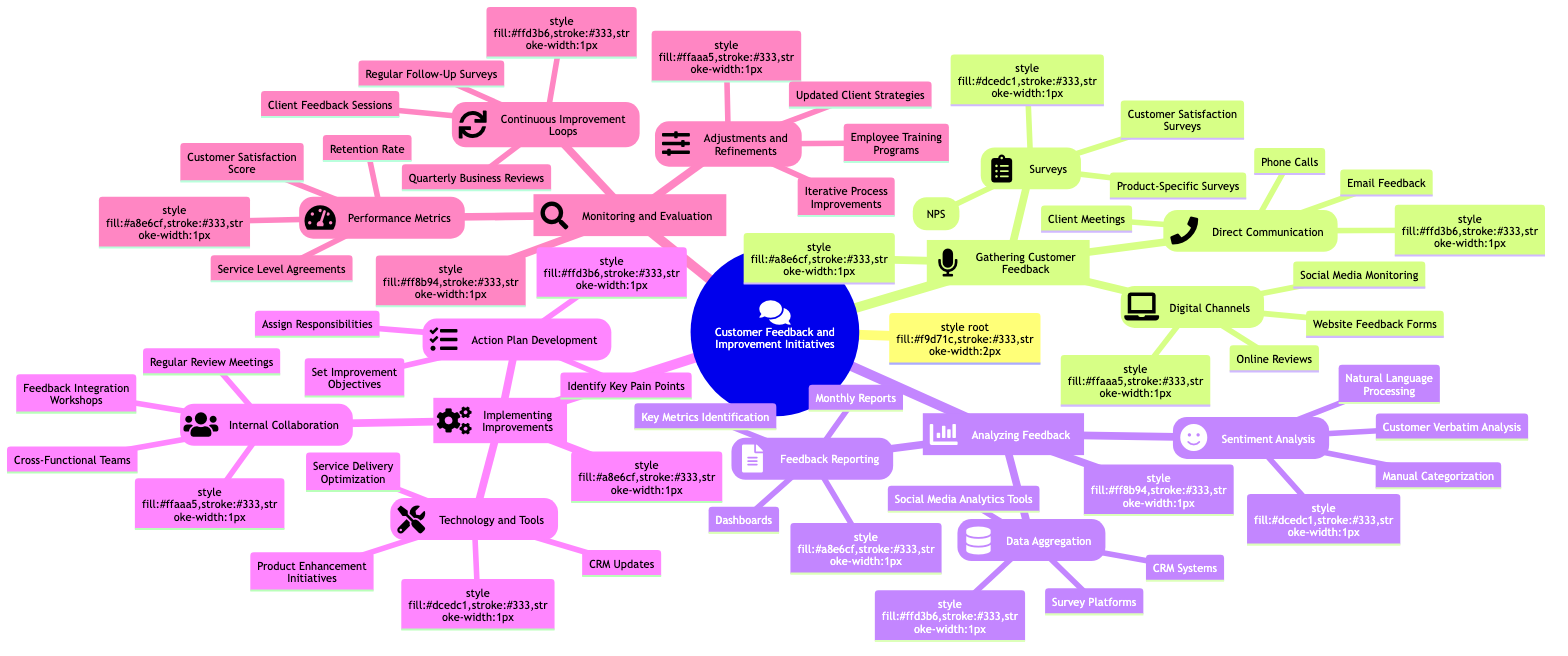What are the methods used for gathering customer feedback? The diagram lists three main categories under gathering customer feedback: Surveys, Direct Communication, and Digital Channels. The specific methods are mentioned under each category, such as Customer Satisfaction Surveys and Online Reviews.
Answer: Surveys, Direct Communication, Digital Channels How many types of sentiment analysis methods are there? In the diagram, there are three distinct methods listed under Sentiment Analysis: Natural Language Processing, Manual Categorization, and Customer Verbatim Analysis. This counts as three types.
Answer: 3 What are the components of Action Plan Development? The mind map outlines three components under Action Plan Development: Identify Key Pain Points, Set Improvement Objectives, and Assign Responsibilities. These components are grouped together, indicating their relationship.
Answer: Identify Key Pain Points, Set Improvement Objectives, Assign Responsibilities Which section contains Technology and Tools for improvements? The Technology and Tools category is located under the Implementing Improvements section of the diagram. The diagram structure shows it as part of the larger process of implementing improvements based on feedback.
Answer: Implementing Improvements Which performance metric specifically measures customer satisfaction? The diagram specifies Customer Satisfaction Score (CSAT) as a performance metric that directly assesses customer satisfaction levels among the other metrics listed. This distinction makes it clear what metric is relevant for customer satisfaction.
Answer: Customer Satisfaction Score What process is emphasized under Continuous Improvement Loops? The diagram highlights three activities in Continuous Improvement Loops: Regular Follow-Up Surveys, Quarterly Business Reviews, and Client Feedback Sessions. This shows a focus on ongoing evaluation and feedback.
Answer: Regular Follow-Up Surveys, Quarterly Business Reviews, Client Feedback Sessions How is internal collaboration achieved according to the diagram? The diagram indicates that internal collaboration is fostered through Cross-Functional Teams, Regular Review Meetings, and Feedback Integration Workshops, which emphasize teamwork and communication among different departments.
Answer: Cross-Functional Teams, Regular Review Meetings, Feedback Integration Workshops What type of analysis is associated with customer feedback reporting? The Feedback Reporting section includes elements like Dashboards, Monthly Reports, and Key Metrics Identification. Each element contributes to how feedback is compiled and presented for analysis.
Answer: Dashboards, Monthly Reports, Key Metrics Identification 